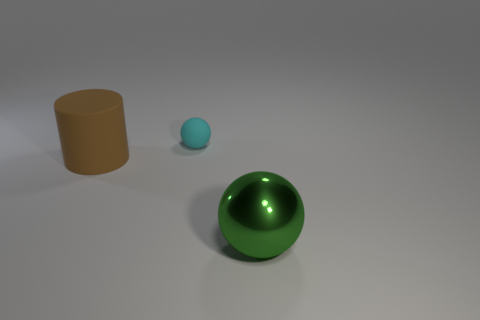What color is the sphere in front of the big brown matte thing?
Offer a very short reply. Green. The ball on the left side of the ball that is in front of the cyan rubber ball is what color?
Offer a very short reply. Cyan. What color is the metal sphere that is the same size as the brown object?
Offer a very short reply. Green. How many objects are both to the left of the large ball and in front of the large brown matte cylinder?
Your answer should be very brief. 0. There is a thing that is both behind the big green object and in front of the tiny thing; what is its material?
Your answer should be compact. Rubber. Are there fewer small rubber things that are behind the cyan object than big green metallic spheres left of the green shiny sphere?
Your answer should be compact. No. The object that is made of the same material as the tiny ball is what size?
Your answer should be compact. Large. Are there any other things that have the same color as the cylinder?
Give a very brief answer. No. Do the big brown cylinder and the sphere that is to the left of the metallic sphere have the same material?
Offer a very short reply. Yes. What is the material of the big green thing that is the same shape as the tiny rubber object?
Ensure brevity in your answer.  Metal. 